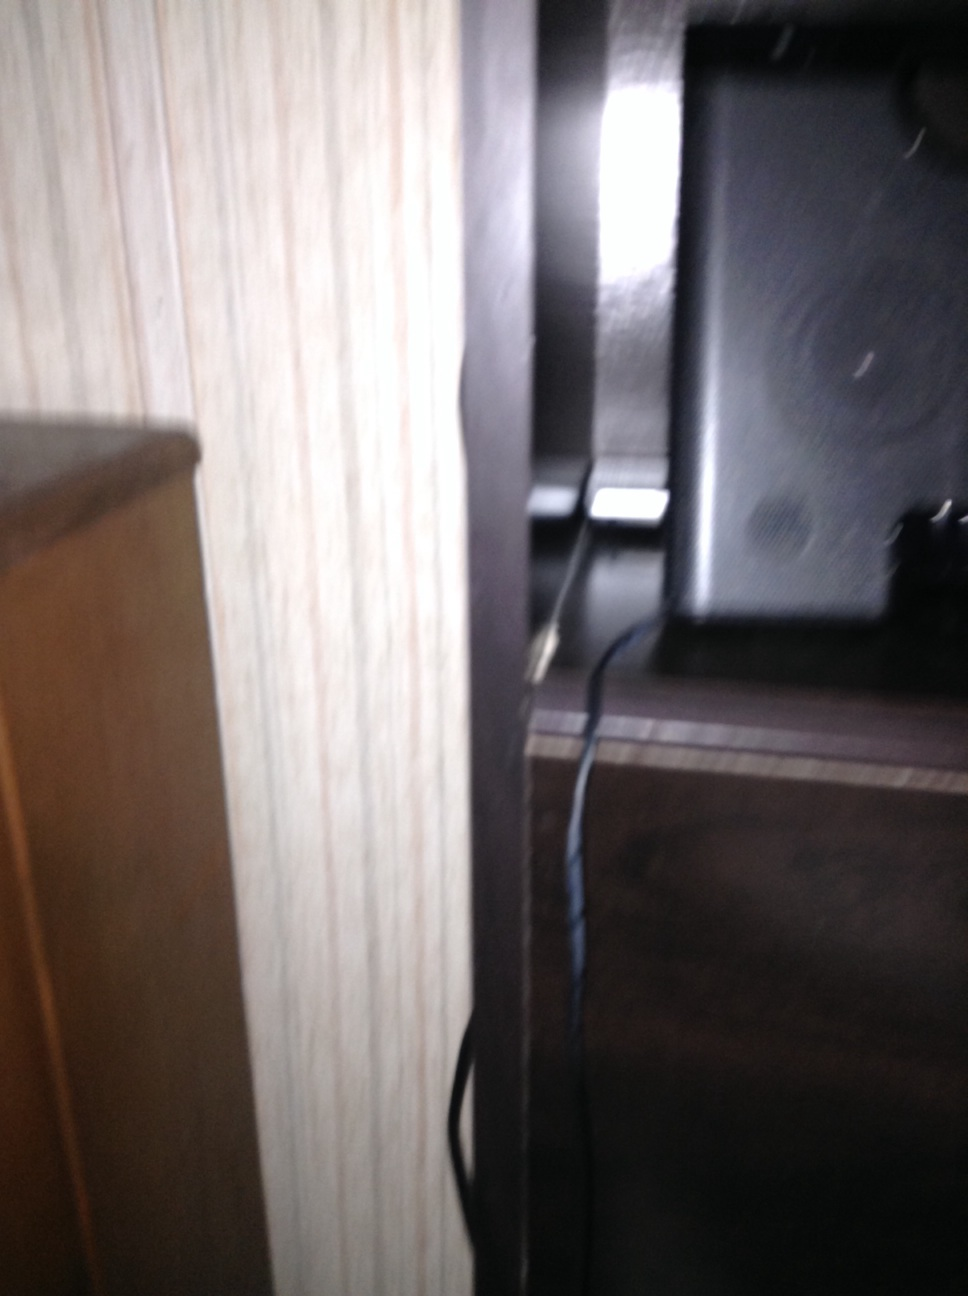Imagine a scenario where this speaker is playing music. Describe the scene. As the speaker plays music, the room likely fills with rich, deep sounds. The ambient lighting might be dimmed, and someone could be relaxing on a nearby couch, enjoying their favorite tunes while reading a book or sipping a cup of coffee. 